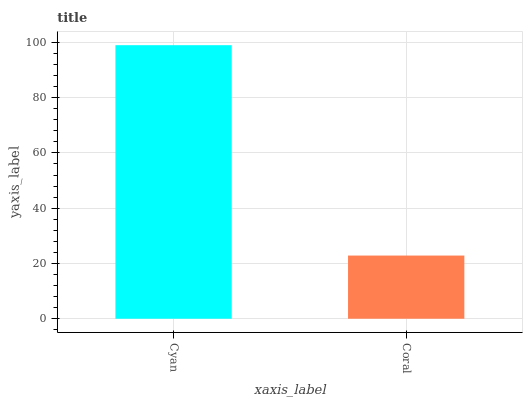Is Coral the maximum?
Answer yes or no. No. Is Cyan greater than Coral?
Answer yes or no. Yes. Is Coral less than Cyan?
Answer yes or no. Yes. Is Coral greater than Cyan?
Answer yes or no. No. Is Cyan less than Coral?
Answer yes or no. No. Is Cyan the high median?
Answer yes or no. Yes. Is Coral the low median?
Answer yes or no. Yes. Is Coral the high median?
Answer yes or no. No. Is Cyan the low median?
Answer yes or no. No. 